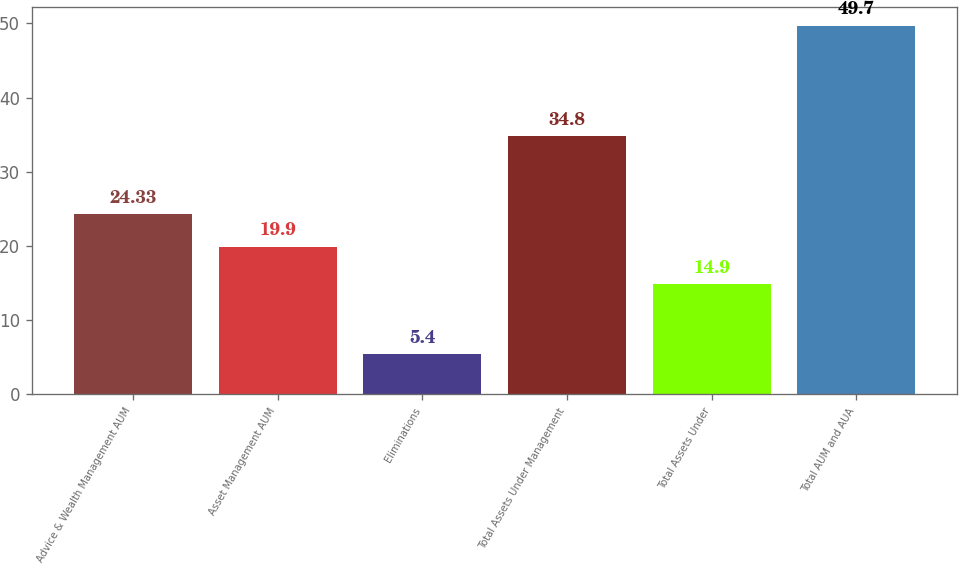Convert chart to OTSL. <chart><loc_0><loc_0><loc_500><loc_500><bar_chart><fcel>Advice & Wealth Management AUM<fcel>Asset Management AUM<fcel>Eliminations<fcel>Total Assets Under Management<fcel>Total Assets Under<fcel>Total AUM and AUA<nl><fcel>24.33<fcel>19.9<fcel>5.4<fcel>34.8<fcel>14.9<fcel>49.7<nl></chart> 